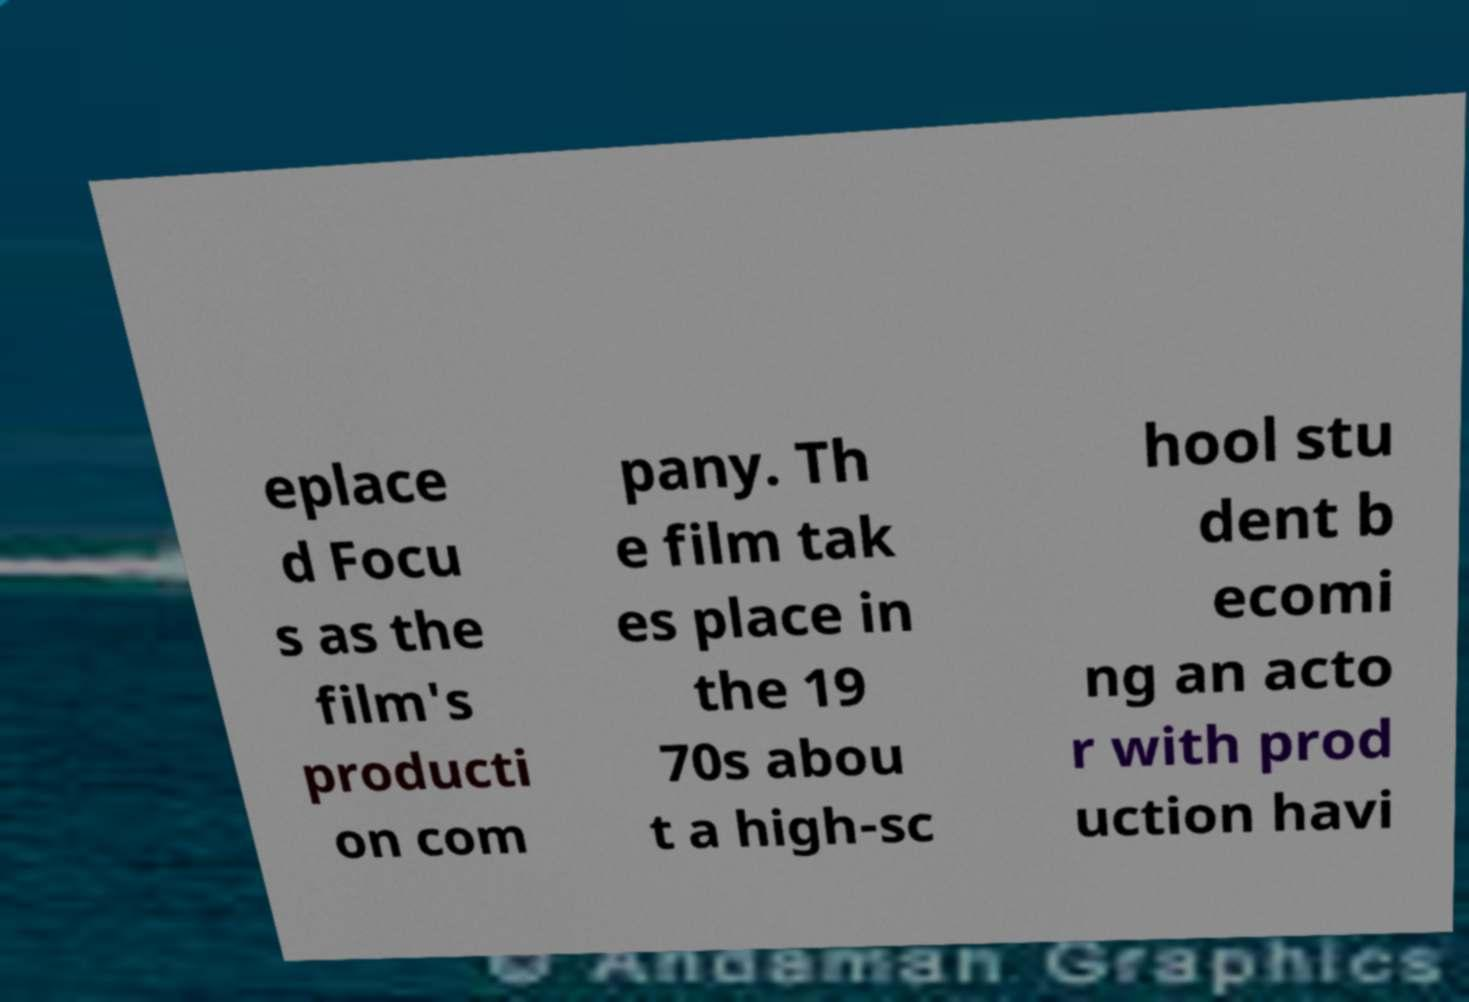There's text embedded in this image that I need extracted. Can you transcribe it verbatim? eplace d Focu s as the film's producti on com pany. Th e film tak es place in the 19 70s abou t a high-sc hool stu dent b ecomi ng an acto r with prod uction havi 